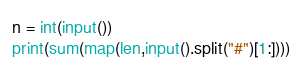Convert code to text. <code><loc_0><loc_0><loc_500><loc_500><_Python_>n = int(input())
print(sum(map(len,input().split("#")[1:])))
</code> 